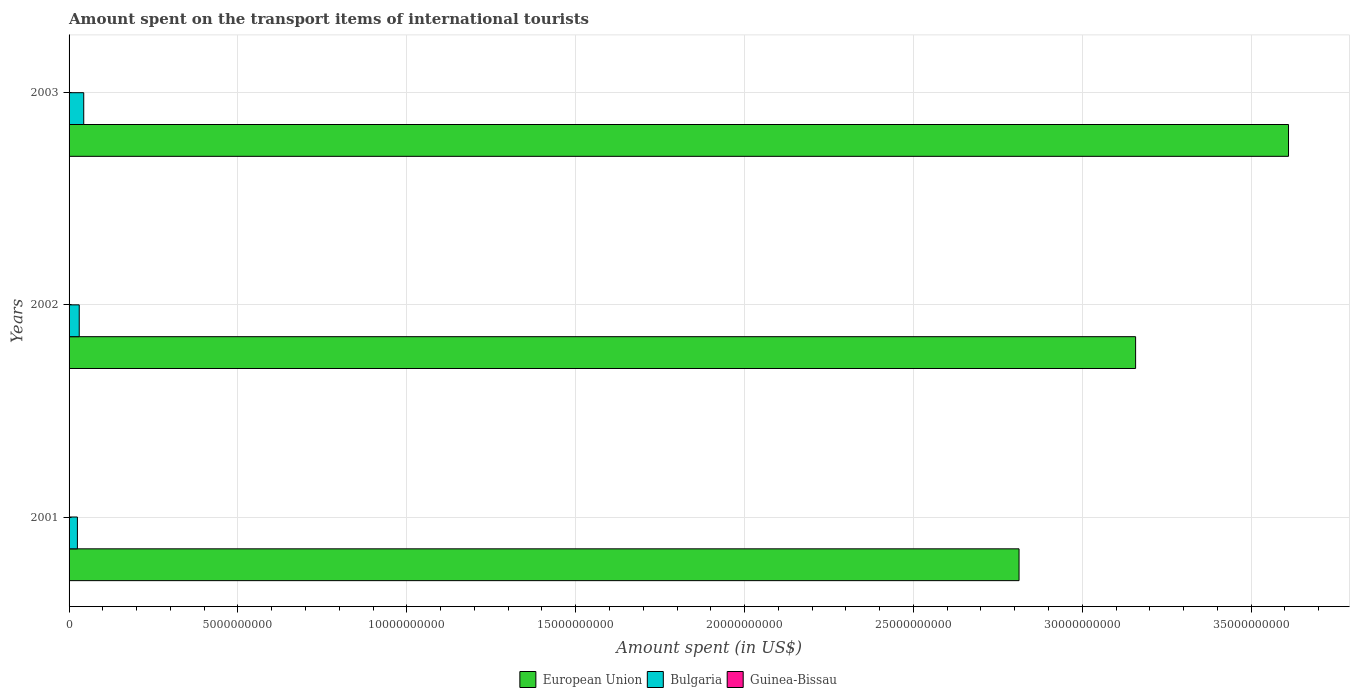How many different coloured bars are there?
Ensure brevity in your answer.  3. Are the number of bars on each tick of the Y-axis equal?
Your answer should be compact. Yes. How many bars are there on the 1st tick from the bottom?
Give a very brief answer. 3. In how many cases, is the number of bars for a given year not equal to the number of legend labels?
Your answer should be compact. 0. What is the amount spent on the transport items of international tourists in European Union in 2001?
Keep it short and to the point. 2.81e+1. Across all years, what is the maximum amount spent on the transport items of international tourists in European Union?
Your response must be concise. 3.61e+1. Across all years, what is the minimum amount spent on the transport items of international tourists in Bulgaria?
Make the answer very short. 2.47e+08. In which year was the amount spent on the transport items of international tourists in Guinea-Bissau maximum?
Your answer should be compact. 2003. What is the total amount spent on the transport items of international tourists in European Union in the graph?
Your answer should be compact. 9.58e+1. What is the difference between the amount spent on the transport items of international tourists in European Union in 2001 and that in 2003?
Offer a very short reply. -7.98e+09. What is the difference between the amount spent on the transport items of international tourists in European Union in 2001 and the amount spent on the transport items of international tourists in Guinea-Bissau in 2003?
Your response must be concise. 2.81e+1. What is the average amount spent on the transport items of international tourists in European Union per year?
Your response must be concise. 3.19e+1. In the year 2001, what is the difference between the amount spent on the transport items of international tourists in European Union and amount spent on the transport items of international tourists in Guinea-Bissau?
Offer a terse response. 2.81e+1. In how many years, is the amount spent on the transport items of international tourists in Guinea-Bissau greater than 22000000000 US$?
Keep it short and to the point. 0. What is the ratio of the amount spent on the transport items of international tourists in Guinea-Bissau in 2002 to that in 2003?
Provide a short and direct response. 0.64. Is the amount spent on the transport items of international tourists in Bulgaria in 2002 less than that in 2003?
Provide a short and direct response. Yes. Is the difference between the amount spent on the transport items of international tourists in European Union in 2001 and 2003 greater than the difference between the amount spent on the transport items of international tourists in Guinea-Bissau in 2001 and 2003?
Your answer should be very brief. No. What is the difference between the highest and the second highest amount spent on the transport items of international tourists in European Union?
Your answer should be very brief. 4.53e+09. What is the difference between the highest and the lowest amount spent on the transport items of international tourists in Bulgaria?
Give a very brief answer. 1.87e+08. Is the sum of the amount spent on the transport items of international tourists in European Union in 2001 and 2002 greater than the maximum amount spent on the transport items of international tourists in Bulgaria across all years?
Your answer should be compact. Yes. What does the 1st bar from the top in 2003 represents?
Offer a very short reply. Guinea-Bissau. What does the 1st bar from the bottom in 2003 represents?
Your response must be concise. European Union. Are all the bars in the graph horizontal?
Your answer should be compact. Yes. Does the graph contain any zero values?
Offer a terse response. No. Where does the legend appear in the graph?
Your answer should be compact. Bottom center. How many legend labels are there?
Keep it short and to the point. 3. What is the title of the graph?
Make the answer very short. Amount spent on the transport items of international tourists. What is the label or title of the X-axis?
Give a very brief answer. Amount spent (in US$). What is the Amount spent (in US$) of European Union in 2001?
Your response must be concise. 2.81e+1. What is the Amount spent (in US$) in Bulgaria in 2001?
Your answer should be compact. 2.47e+08. What is the Amount spent (in US$) of Guinea-Bissau in 2001?
Give a very brief answer. 2.70e+06. What is the Amount spent (in US$) of European Union in 2002?
Give a very brief answer. 3.16e+1. What is the Amount spent (in US$) of Bulgaria in 2002?
Provide a short and direct response. 3.01e+08. What is the Amount spent (in US$) in Guinea-Bissau in 2002?
Make the answer very short. 5.10e+06. What is the Amount spent (in US$) of European Union in 2003?
Offer a very short reply. 3.61e+1. What is the Amount spent (in US$) in Bulgaria in 2003?
Make the answer very short. 4.34e+08. Across all years, what is the maximum Amount spent (in US$) of European Union?
Keep it short and to the point. 3.61e+1. Across all years, what is the maximum Amount spent (in US$) of Bulgaria?
Offer a terse response. 4.34e+08. Across all years, what is the minimum Amount spent (in US$) of European Union?
Give a very brief answer. 2.81e+1. Across all years, what is the minimum Amount spent (in US$) in Bulgaria?
Your response must be concise. 2.47e+08. Across all years, what is the minimum Amount spent (in US$) of Guinea-Bissau?
Offer a very short reply. 2.70e+06. What is the total Amount spent (in US$) of European Union in the graph?
Keep it short and to the point. 9.58e+1. What is the total Amount spent (in US$) of Bulgaria in the graph?
Give a very brief answer. 9.82e+08. What is the total Amount spent (in US$) of Guinea-Bissau in the graph?
Keep it short and to the point. 1.58e+07. What is the difference between the Amount spent (in US$) in European Union in 2001 and that in 2002?
Offer a very short reply. -3.45e+09. What is the difference between the Amount spent (in US$) in Bulgaria in 2001 and that in 2002?
Your answer should be very brief. -5.40e+07. What is the difference between the Amount spent (in US$) in Guinea-Bissau in 2001 and that in 2002?
Give a very brief answer. -2.40e+06. What is the difference between the Amount spent (in US$) in European Union in 2001 and that in 2003?
Provide a short and direct response. -7.98e+09. What is the difference between the Amount spent (in US$) in Bulgaria in 2001 and that in 2003?
Give a very brief answer. -1.87e+08. What is the difference between the Amount spent (in US$) of Guinea-Bissau in 2001 and that in 2003?
Keep it short and to the point. -5.30e+06. What is the difference between the Amount spent (in US$) in European Union in 2002 and that in 2003?
Give a very brief answer. -4.53e+09. What is the difference between the Amount spent (in US$) of Bulgaria in 2002 and that in 2003?
Your response must be concise. -1.33e+08. What is the difference between the Amount spent (in US$) of Guinea-Bissau in 2002 and that in 2003?
Give a very brief answer. -2.90e+06. What is the difference between the Amount spent (in US$) in European Union in 2001 and the Amount spent (in US$) in Bulgaria in 2002?
Your answer should be compact. 2.78e+1. What is the difference between the Amount spent (in US$) of European Union in 2001 and the Amount spent (in US$) of Guinea-Bissau in 2002?
Your response must be concise. 2.81e+1. What is the difference between the Amount spent (in US$) of Bulgaria in 2001 and the Amount spent (in US$) of Guinea-Bissau in 2002?
Your answer should be very brief. 2.42e+08. What is the difference between the Amount spent (in US$) in European Union in 2001 and the Amount spent (in US$) in Bulgaria in 2003?
Provide a short and direct response. 2.77e+1. What is the difference between the Amount spent (in US$) in European Union in 2001 and the Amount spent (in US$) in Guinea-Bissau in 2003?
Give a very brief answer. 2.81e+1. What is the difference between the Amount spent (in US$) in Bulgaria in 2001 and the Amount spent (in US$) in Guinea-Bissau in 2003?
Your answer should be very brief. 2.39e+08. What is the difference between the Amount spent (in US$) of European Union in 2002 and the Amount spent (in US$) of Bulgaria in 2003?
Your response must be concise. 3.11e+1. What is the difference between the Amount spent (in US$) of European Union in 2002 and the Amount spent (in US$) of Guinea-Bissau in 2003?
Keep it short and to the point. 3.16e+1. What is the difference between the Amount spent (in US$) of Bulgaria in 2002 and the Amount spent (in US$) of Guinea-Bissau in 2003?
Keep it short and to the point. 2.93e+08. What is the average Amount spent (in US$) of European Union per year?
Keep it short and to the point. 3.19e+1. What is the average Amount spent (in US$) in Bulgaria per year?
Provide a succinct answer. 3.27e+08. What is the average Amount spent (in US$) in Guinea-Bissau per year?
Give a very brief answer. 5.27e+06. In the year 2001, what is the difference between the Amount spent (in US$) in European Union and Amount spent (in US$) in Bulgaria?
Make the answer very short. 2.79e+1. In the year 2001, what is the difference between the Amount spent (in US$) of European Union and Amount spent (in US$) of Guinea-Bissau?
Your answer should be very brief. 2.81e+1. In the year 2001, what is the difference between the Amount spent (in US$) of Bulgaria and Amount spent (in US$) of Guinea-Bissau?
Make the answer very short. 2.44e+08. In the year 2002, what is the difference between the Amount spent (in US$) of European Union and Amount spent (in US$) of Bulgaria?
Ensure brevity in your answer.  3.13e+1. In the year 2002, what is the difference between the Amount spent (in US$) in European Union and Amount spent (in US$) in Guinea-Bissau?
Provide a succinct answer. 3.16e+1. In the year 2002, what is the difference between the Amount spent (in US$) of Bulgaria and Amount spent (in US$) of Guinea-Bissau?
Your response must be concise. 2.96e+08. In the year 2003, what is the difference between the Amount spent (in US$) of European Union and Amount spent (in US$) of Bulgaria?
Keep it short and to the point. 3.57e+1. In the year 2003, what is the difference between the Amount spent (in US$) in European Union and Amount spent (in US$) in Guinea-Bissau?
Offer a terse response. 3.61e+1. In the year 2003, what is the difference between the Amount spent (in US$) of Bulgaria and Amount spent (in US$) of Guinea-Bissau?
Offer a terse response. 4.26e+08. What is the ratio of the Amount spent (in US$) of European Union in 2001 to that in 2002?
Provide a succinct answer. 0.89. What is the ratio of the Amount spent (in US$) of Bulgaria in 2001 to that in 2002?
Ensure brevity in your answer.  0.82. What is the ratio of the Amount spent (in US$) in Guinea-Bissau in 2001 to that in 2002?
Your response must be concise. 0.53. What is the ratio of the Amount spent (in US$) in European Union in 2001 to that in 2003?
Give a very brief answer. 0.78. What is the ratio of the Amount spent (in US$) in Bulgaria in 2001 to that in 2003?
Provide a succinct answer. 0.57. What is the ratio of the Amount spent (in US$) in Guinea-Bissau in 2001 to that in 2003?
Make the answer very short. 0.34. What is the ratio of the Amount spent (in US$) in European Union in 2002 to that in 2003?
Your answer should be compact. 0.87. What is the ratio of the Amount spent (in US$) in Bulgaria in 2002 to that in 2003?
Your answer should be compact. 0.69. What is the ratio of the Amount spent (in US$) in Guinea-Bissau in 2002 to that in 2003?
Your answer should be compact. 0.64. What is the difference between the highest and the second highest Amount spent (in US$) of European Union?
Your answer should be compact. 4.53e+09. What is the difference between the highest and the second highest Amount spent (in US$) of Bulgaria?
Keep it short and to the point. 1.33e+08. What is the difference between the highest and the second highest Amount spent (in US$) in Guinea-Bissau?
Your response must be concise. 2.90e+06. What is the difference between the highest and the lowest Amount spent (in US$) of European Union?
Your response must be concise. 7.98e+09. What is the difference between the highest and the lowest Amount spent (in US$) of Bulgaria?
Keep it short and to the point. 1.87e+08. What is the difference between the highest and the lowest Amount spent (in US$) in Guinea-Bissau?
Your answer should be very brief. 5.30e+06. 